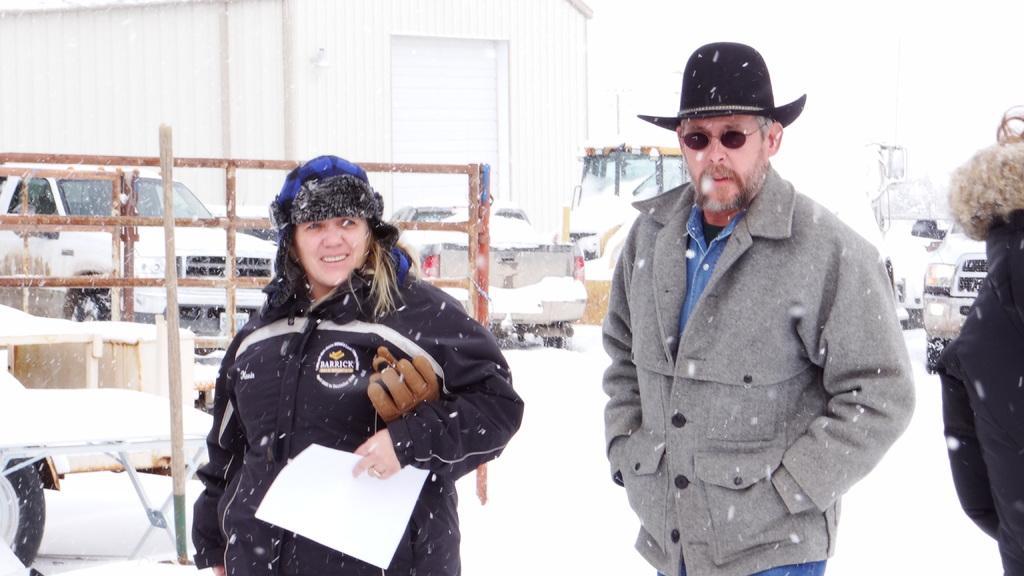Could you give a brief overview of what you see in this image? In this image I can see few vehicles, a building, snow and here I can see few people are standing. I can see they all are wearing jackets and she is holding a white colour paper. Here I can see he is wearing shades and black colour hat. 